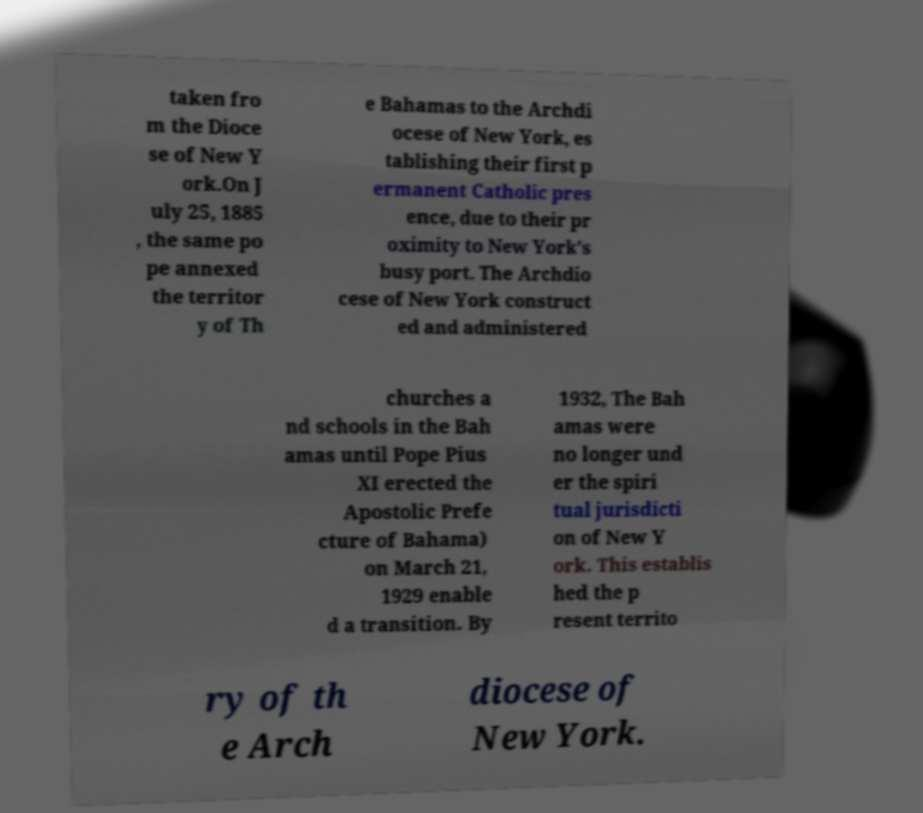I need the written content from this picture converted into text. Can you do that? taken fro m the Dioce se of New Y ork.On J uly 25, 1885 , the same po pe annexed the territor y of Th e Bahamas to the Archdi ocese of New York, es tablishing their first p ermanent Catholic pres ence, due to their pr oximity to New York's busy port. The Archdio cese of New York construct ed and administered churches a nd schools in the Bah amas until Pope Pius XI erected the Apostolic Prefe cture of Bahama) on March 21, 1929 enable d a transition. By 1932, The Bah amas were no longer und er the spiri tual jurisdicti on of New Y ork. This establis hed the p resent territo ry of th e Arch diocese of New York. 